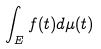<formula> <loc_0><loc_0><loc_500><loc_500>\int _ { E } f ( t ) d \mu ( t )</formula> 